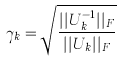Convert formula to latex. <formula><loc_0><loc_0><loc_500><loc_500>\gamma _ { k } = \sqrt { \frac { | | U _ { k } ^ { - 1 } | | _ { F } } { | | U _ { k } | | _ { F } } }</formula> 